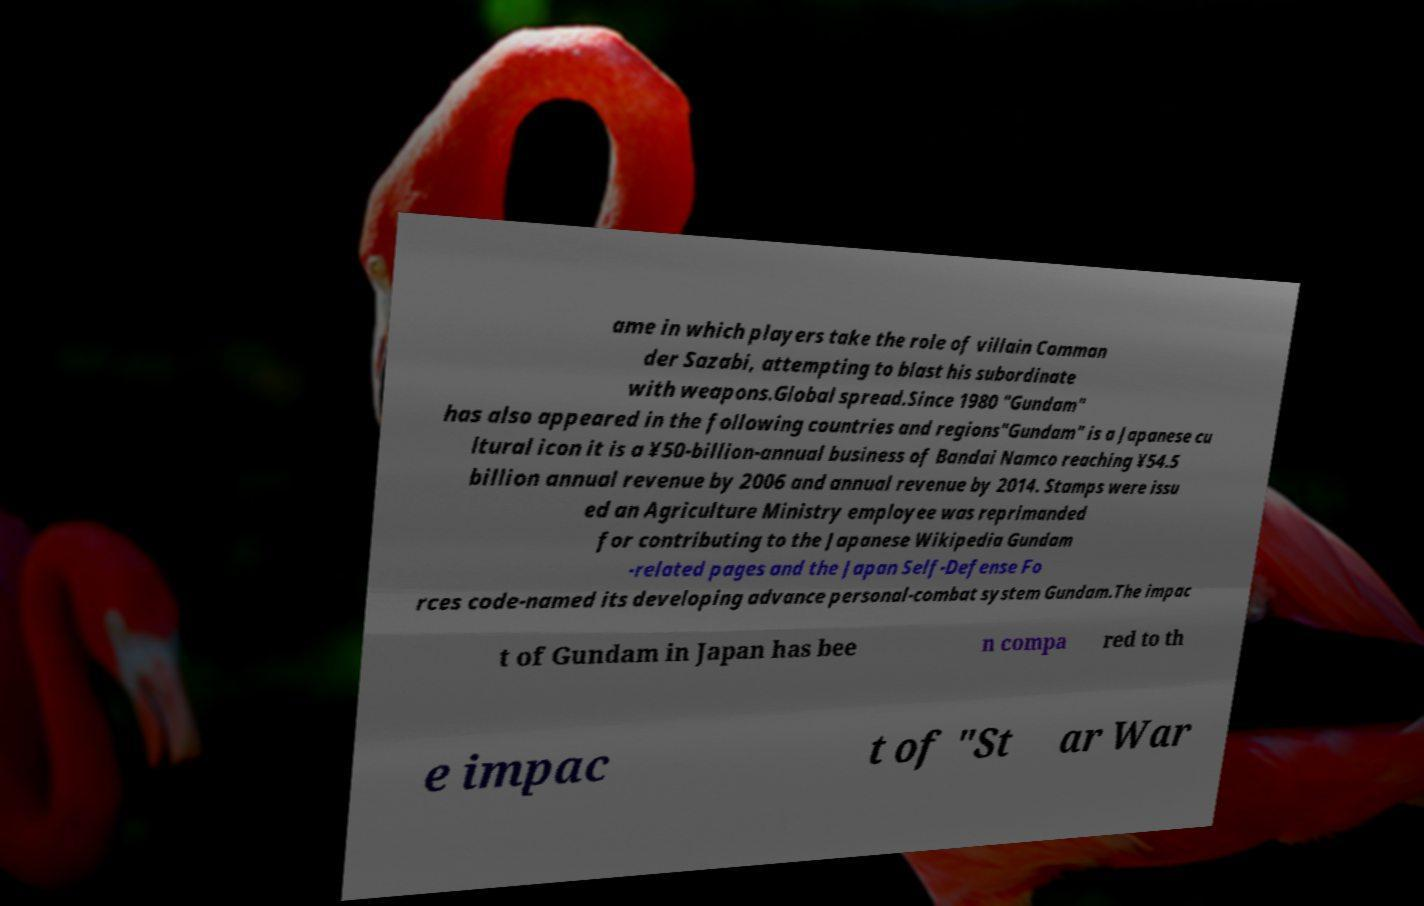Please read and relay the text visible in this image. What does it say? ame in which players take the role of villain Comman der Sazabi, attempting to blast his subordinate with weapons.Global spread.Since 1980 "Gundam" has also appeared in the following countries and regions"Gundam" is a Japanese cu ltural icon it is a ¥50-billion-annual business of Bandai Namco reaching ¥54.5 billion annual revenue by 2006 and annual revenue by 2014. Stamps were issu ed an Agriculture Ministry employee was reprimanded for contributing to the Japanese Wikipedia Gundam -related pages and the Japan Self-Defense Fo rces code-named its developing advance personal-combat system Gundam.The impac t of Gundam in Japan has bee n compa red to th e impac t of "St ar War 